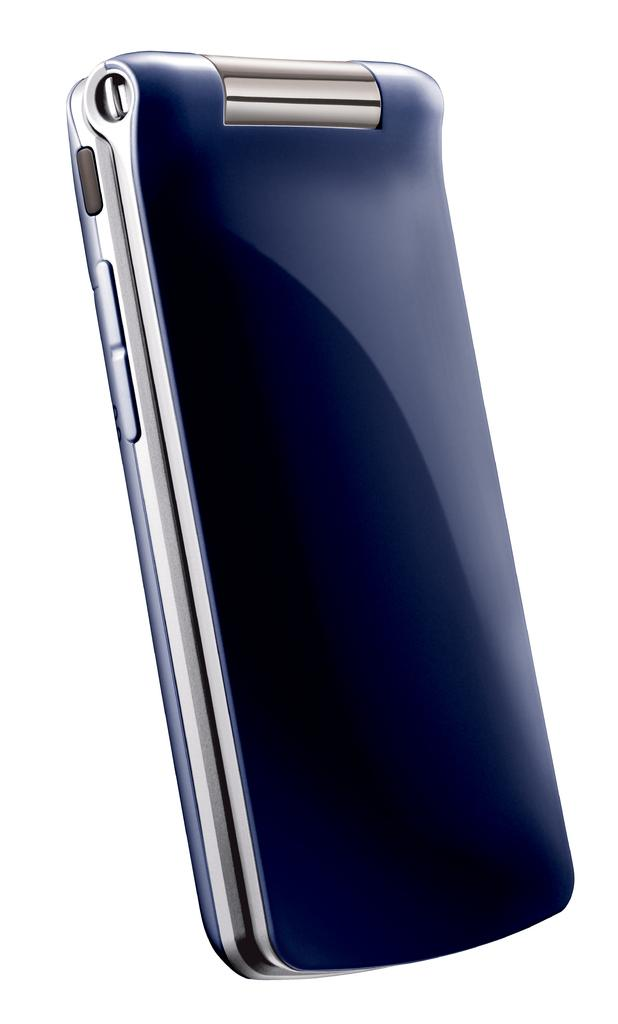What type of phone is visible in the image? There is a blue color phone in the image. What color is the background of the image? The background color of the image is white. How many eggs are present in the garden in the image? There are no eggs or gardens present in the image; it only features a blue color phone against a white background. 